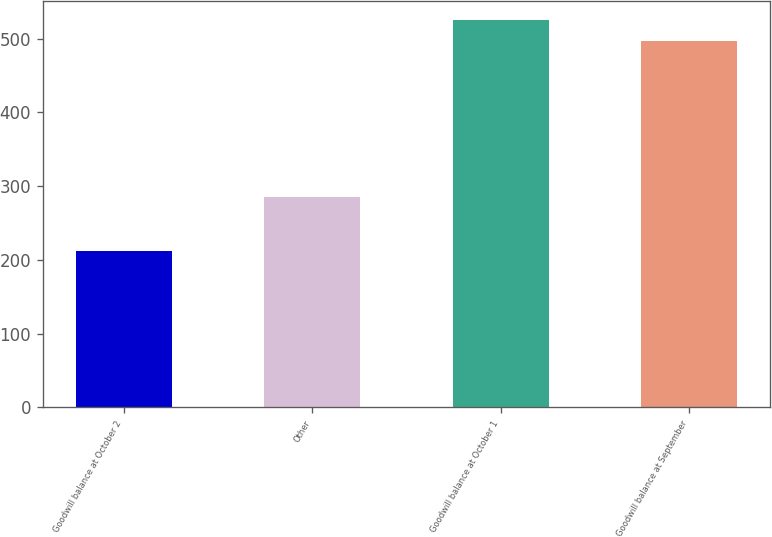Convert chart. <chart><loc_0><loc_0><loc_500><loc_500><bar_chart><fcel>Goodwill balance at October 2<fcel>Other<fcel>Goodwill balance at October 1<fcel>Goodwill balance at September<nl><fcel>211.6<fcel>285.8<fcel>525.28<fcel>496.7<nl></chart> 